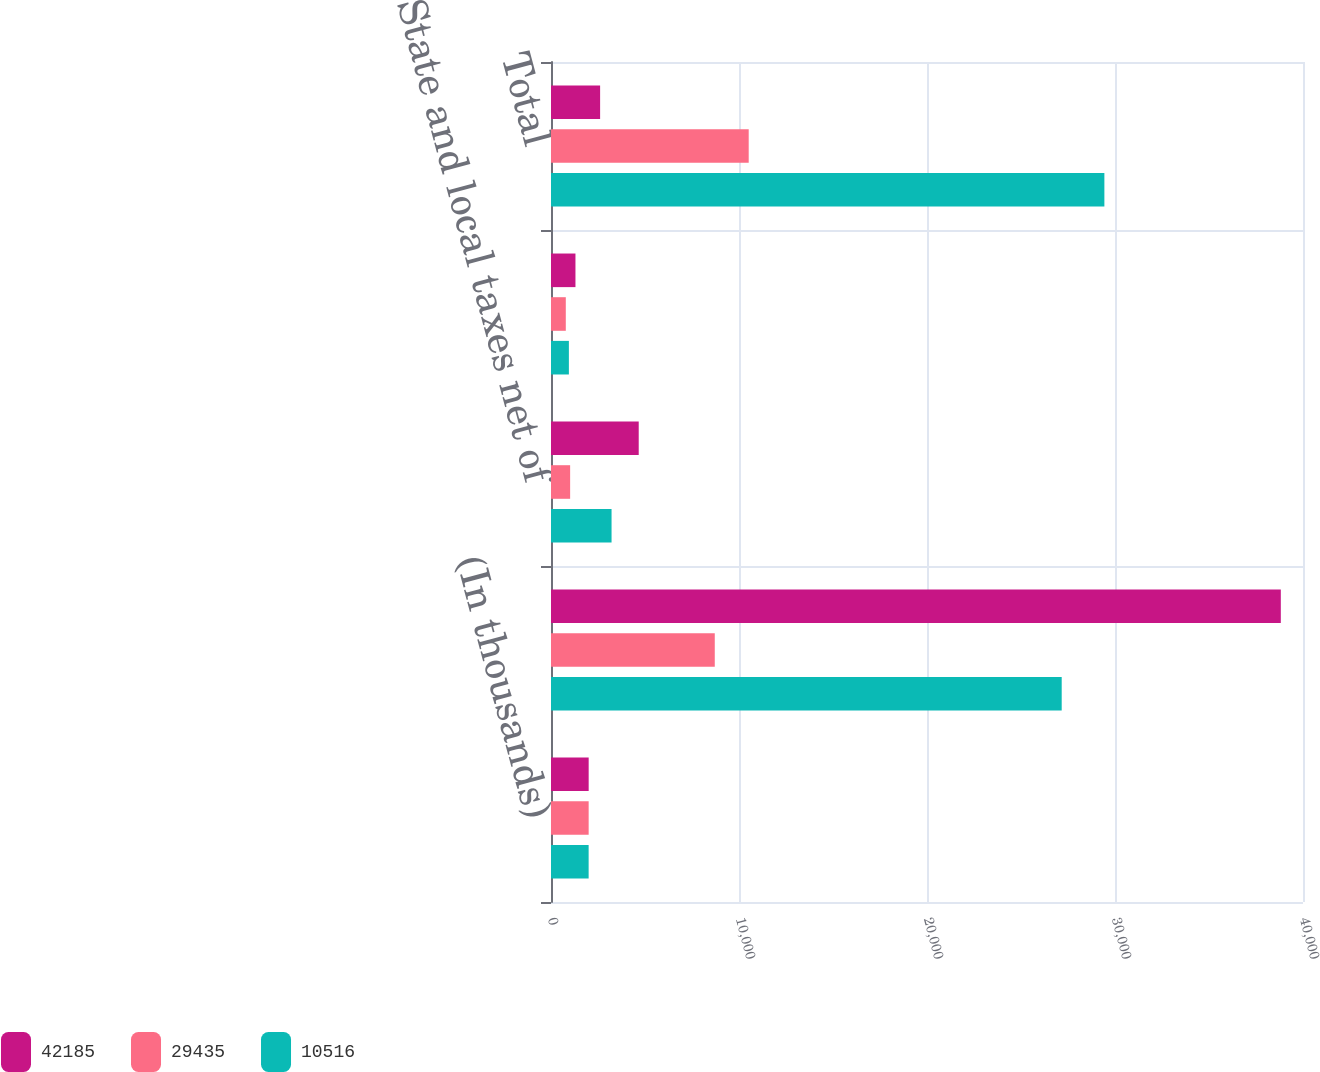<chart> <loc_0><loc_0><loc_500><loc_500><stacked_bar_chart><ecel><fcel>(In thousands)<fcel>Provision computed at US<fcel>State and local taxes net of<fcel>Other<fcel>Total<nl><fcel>42185<fcel>2004<fcel>38820<fcel>4666<fcel>1301<fcel>2612.5<nl><fcel>29435<fcel>2003<fcel>8711<fcel>1018<fcel>787<fcel>10516<nl><fcel>10516<fcel>2002<fcel>27165<fcel>3221<fcel>951<fcel>29435<nl></chart> 